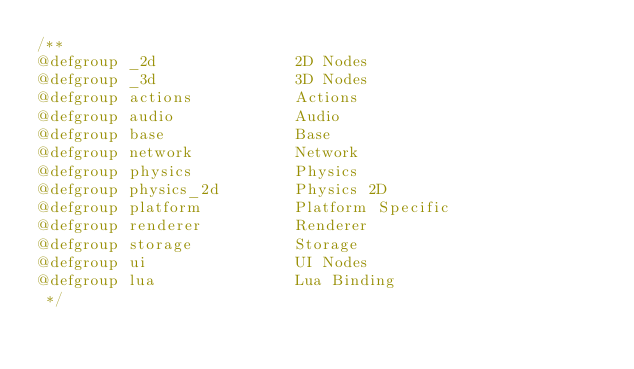<code> <loc_0><loc_0><loc_500><loc_500><_C_>/**
@defgroup _2d               2D Nodes
@defgroup _3d               3D Nodes
@defgroup actions           Actions
@defgroup audio             Audio
@defgroup base              Base
@defgroup network           Network
@defgroup physics           Physics
@defgroup physics_2d        Physics 2D
@defgroup platform          Platform Specific
@defgroup renderer          Renderer
@defgroup storage           Storage
@defgroup ui                UI Nodes
@defgroup lua               Lua Binding
 */
</code> 